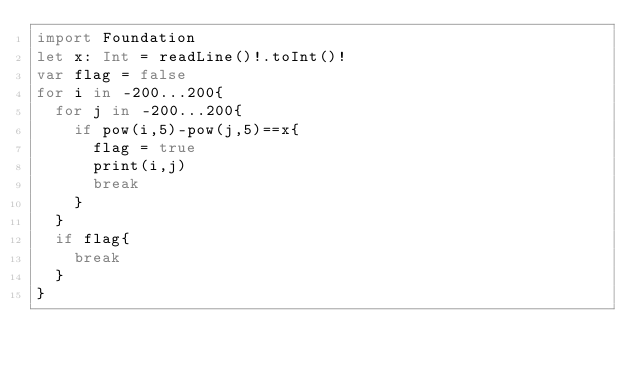<code> <loc_0><loc_0><loc_500><loc_500><_Swift_>import Foundation
let x: Int = readLine()!.toInt()!
var flag = false
for i in -200...200{
  for j in -200...200{
    if pow(i,5)-pow(j,5)==x{
      flag = true
      print(i,j)
      break
    }
  }
  if flag{
    break
  }
}</code> 